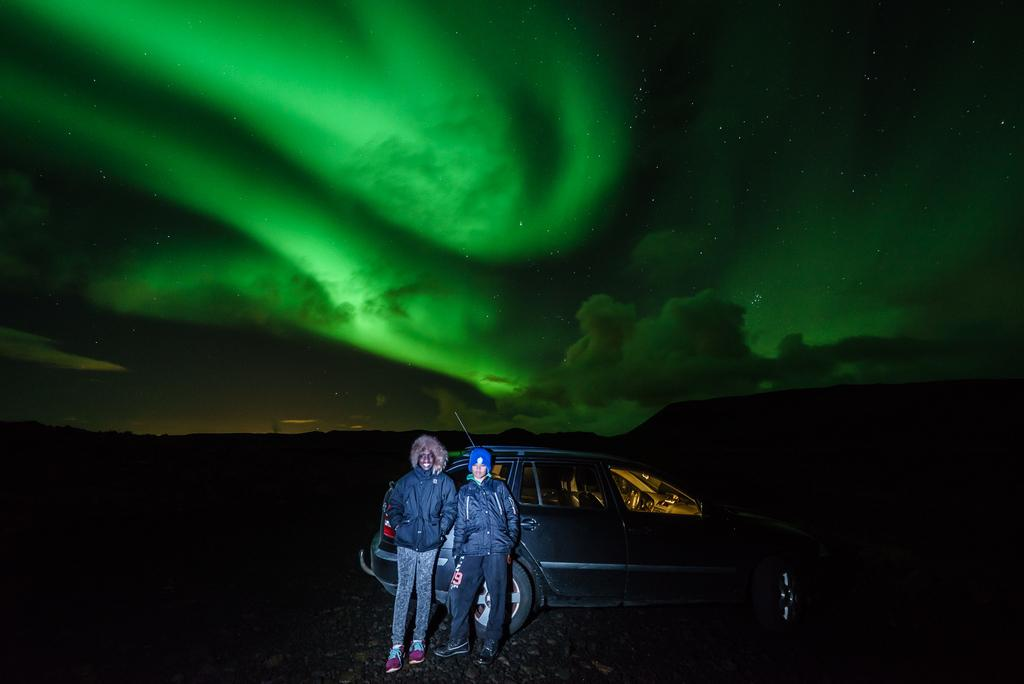How many people are in the image? There are two men in the image. What are the men doing in the image? The men are standing beside a car. Can you describe the position of the car in the image? The car is placed on the ground. What can be seen in the background of the image? Hills and the sky are visible in the background of the image. How would you describe the sky in the image? The sky appears cloudy in the image. Is there any poison visible in the image? There is no mention of poison or any toxic substances in the image; it features two men standing beside a car with hills and a cloudy sky in the background. 